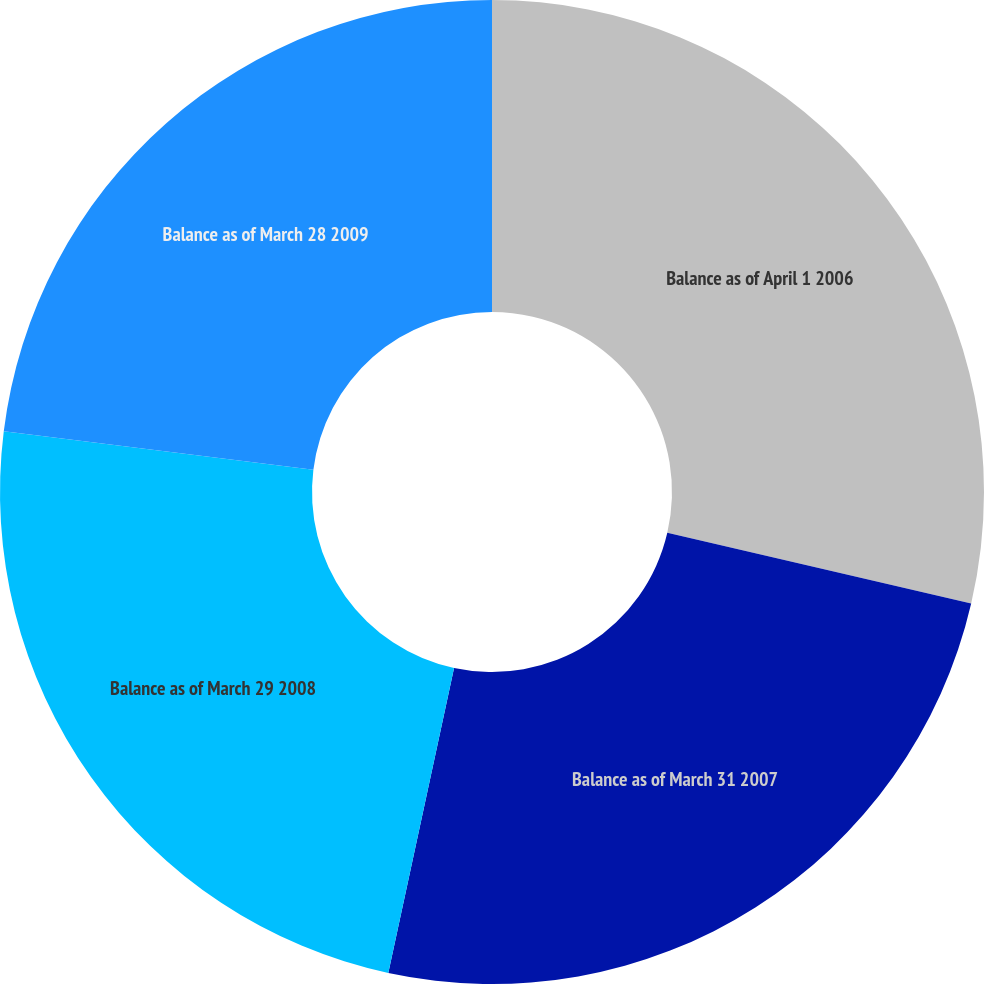Convert chart to OTSL. <chart><loc_0><loc_0><loc_500><loc_500><pie_chart><fcel>Balance as of April 1 2006<fcel>Balance as of March 31 2007<fcel>Balance as of March 29 2008<fcel>Balance as of March 28 2009<nl><fcel>28.64%<fcel>24.74%<fcel>23.59%<fcel>23.03%<nl></chart> 